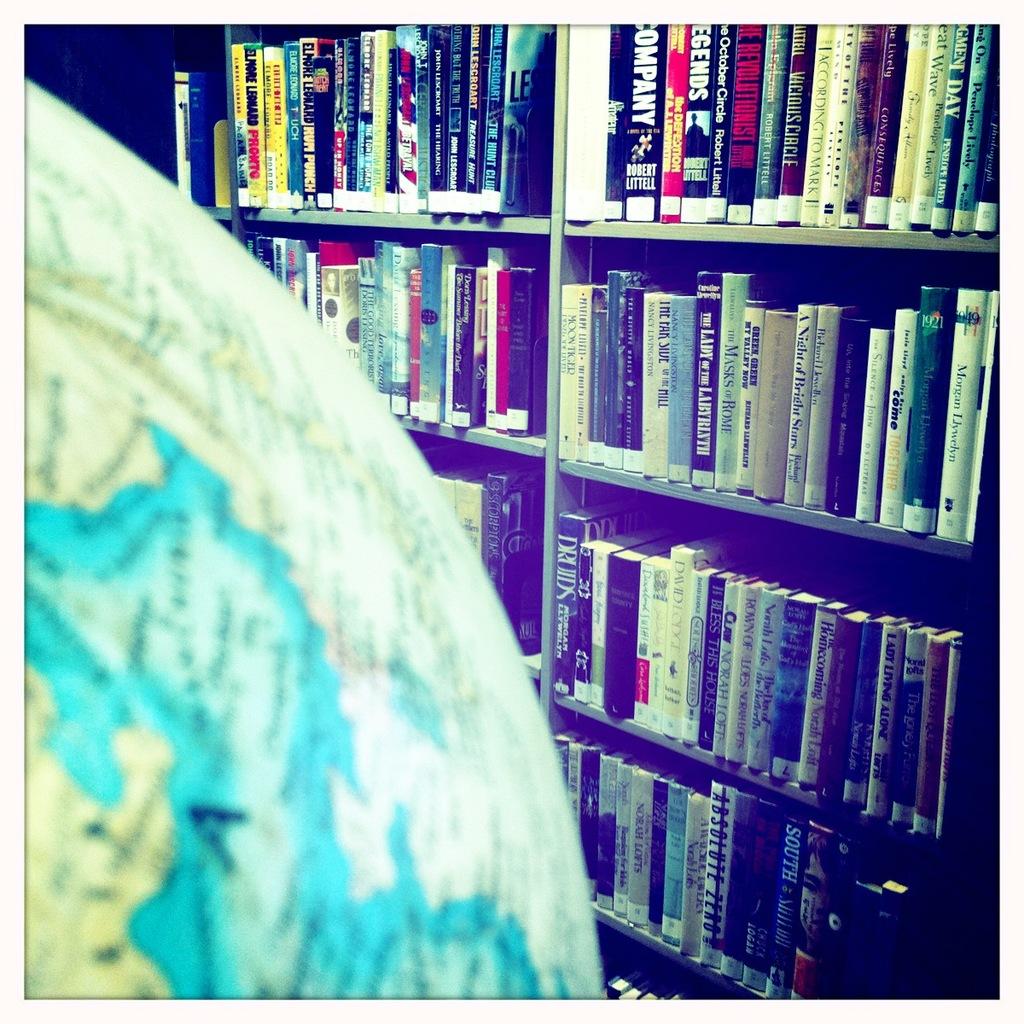What is the title of the book written by eleanor leonard?
Your answer should be very brief. Unanswerable. 